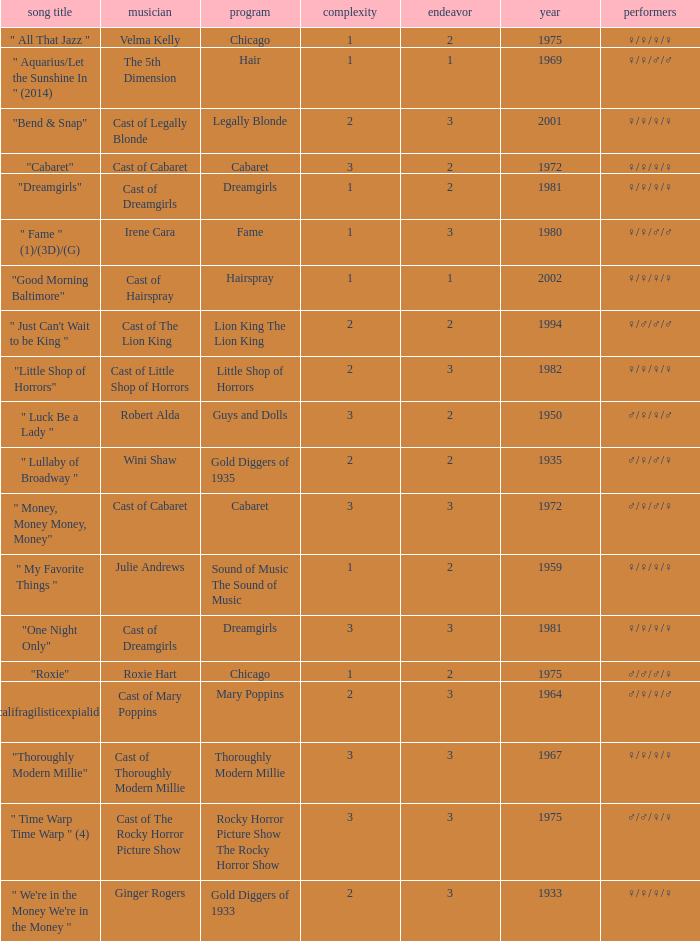How many shows were in 1994? 1.0. Would you be able to parse every entry in this table? {'header': ['song title', 'musician', 'program', 'complexity', 'endeavor', 'year', 'performers'], 'rows': [['" All That Jazz "', 'Velma Kelly', 'Chicago', '1', '2', '1975', '♀/♀/♀/♀'], ['" Aquarius/Let the Sunshine In " (2014)', 'The 5th Dimension', 'Hair', '1', '1', '1969', '♀/♀/♂/♂'], ['"Bend & Snap"', 'Cast of Legally Blonde', 'Legally Blonde', '2', '3', '2001', '♀/♀/♀/♀'], ['"Cabaret"', 'Cast of Cabaret', 'Cabaret', '3', '2', '1972', '♀/♀/♀/♀'], ['"Dreamgirls"', 'Cast of Dreamgirls', 'Dreamgirls', '1', '2', '1981', '♀/♀/♀/♀'], ['" Fame " (1)/(3D)/(G)', 'Irene Cara', 'Fame', '1', '3', '1980', '♀/♀/♂/♂'], ['"Good Morning Baltimore"', 'Cast of Hairspray', 'Hairspray', '1', '1', '2002', '♀/♀/♀/♀'], ['" Just Can\'t Wait to be King "', 'Cast of The Lion King', 'Lion King The Lion King', '2', '2', '1994', '♀/♂/♂/♂'], ['"Little Shop of Horrors"', 'Cast of Little Shop of Horrors', 'Little Shop of Horrors', '2', '3', '1982', '♀/♀/♀/♀'], ['" Luck Be a Lady "', 'Robert Alda', 'Guys and Dolls', '3', '2', '1950', '♂/♀/♀/♂'], ['" Lullaby of Broadway "', 'Wini Shaw', 'Gold Diggers of 1935', '2', '2', '1935', '♂/♀/♂/♀'], ['" Money, Money Money, Money"', 'Cast of Cabaret', 'Cabaret', '3', '3', '1972', '♂/♀/♂/♀'], ['" My Favorite Things "', 'Julie Andrews', 'Sound of Music The Sound of Music', '1', '2', '1959', '♀/♀/♀/♀'], ['"One Night Only"', 'Cast of Dreamgirls', 'Dreamgirls', '3', '3', '1981', '♀/♀/♀/♀'], ['"Roxie"', 'Roxie Hart', 'Chicago', '1', '2', '1975', '♂/♂/♂/♀'], ['" Supercalifragilisticexpialidocious " (DP)', 'Cast of Mary Poppins', 'Mary Poppins', '2', '3', '1964', '♂/♀/♀/♂'], ['"Thoroughly Modern Millie"', 'Cast of Thoroughly Modern Millie', 'Thoroughly Modern Millie', '3', '3', '1967', '♀/♀/♀/♀'], ['" Time Warp Time Warp " (4)', 'Cast of The Rocky Horror Picture Show', 'Rocky Horror Picture Show The Rocky Horror Show', '3', '3', '1975', '♂/♂/♀/♀'], ['" We\'re in the Money We\'re in the Money "', 'Ginger Rogers', 'Gold Diggers of 1933', '2', '3', '1933', '♀/♀/♀/♀']]} 